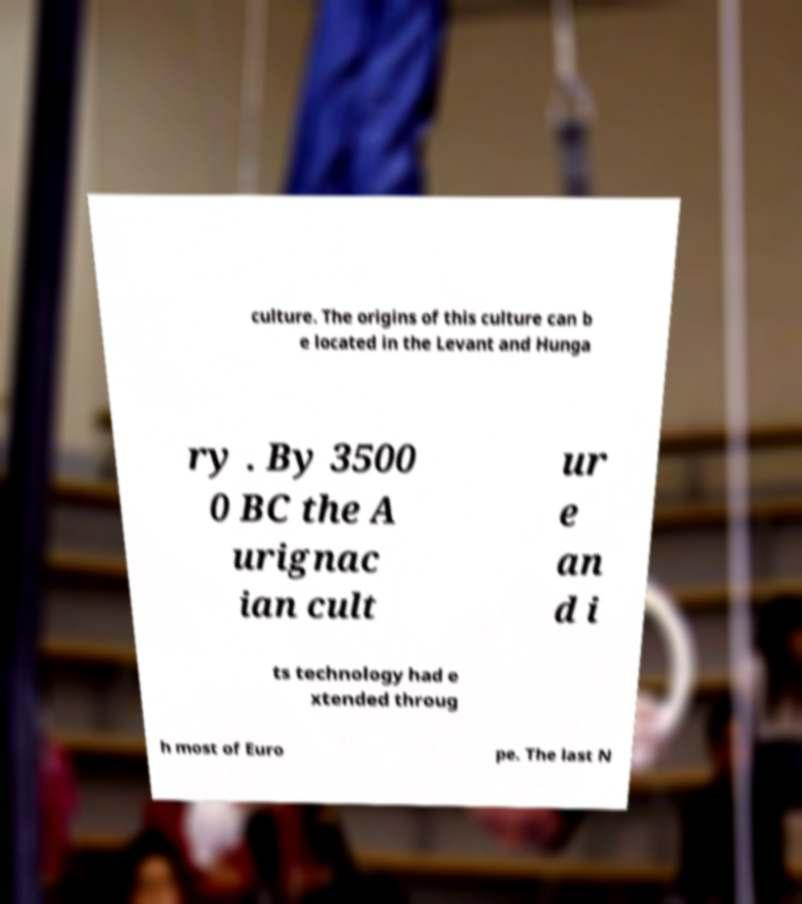Can you accurately transcribe the text from the provided image for me? culture. The origins of this culture can b e located in the Levant and Hunga ry . By 3500 0 BC the A urignac ian cult ur e an d i ts technology had e xtended throug h most of Euro pe. The last N 